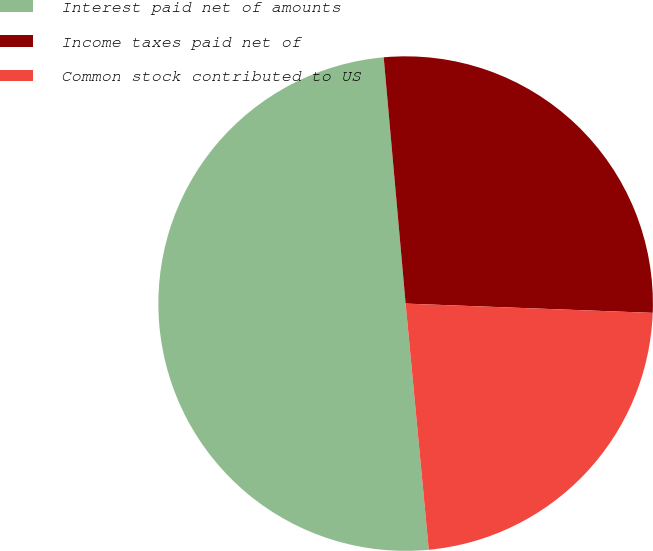Convert chart to OTSL. <chart><loc_0><loc_0><loc_500><loc_500><pie_chart><fcel>Interest paid net of amounts<fcel>Income taxes paid net of<fcel>Common stock contributed to US<nl><fcel>50.08%<fcel>27.01%<fcel>22.91%<nl></chart> 